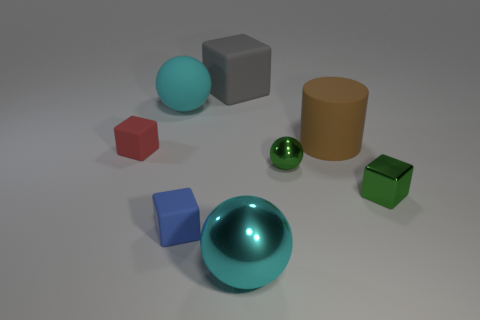Subtract all cyan shiny spheres. How many spheres are left? 2 Add 1 brown matte cylinders. How many objects exist? 9 Subtract all brown cylinders. How many cyan spheres are left? 2 Subtract all red cubes. How many cubes are left? 3 Subtract all cylinders. How many objects are left? 7 Add 8 green balls. How many green balls exist? 9 Subtract 0 blue cylinders. How many objects are left? 8 Subtract 1 cylinders. How many cylinders are left? 0 Subtract all blue cylinders. Subtract all blue blocks. How many cylinders are left? 1 Subtract all large gray objects. Subtract all big matte objects. How many objects are left? 4 